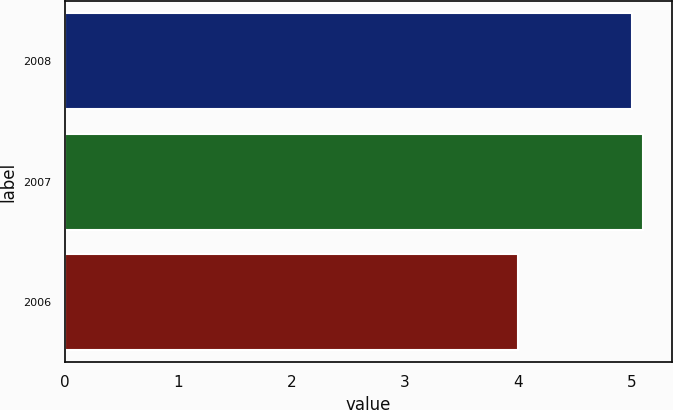Convert chart to OTSL. <chart><loc_0><loc_0><loc_500><loc_500><bar_chart><fcel>2008<fcel>2007<fcel>2006<nl><fcel>5<fcel>5.1<fcel>4<nl></chart> 